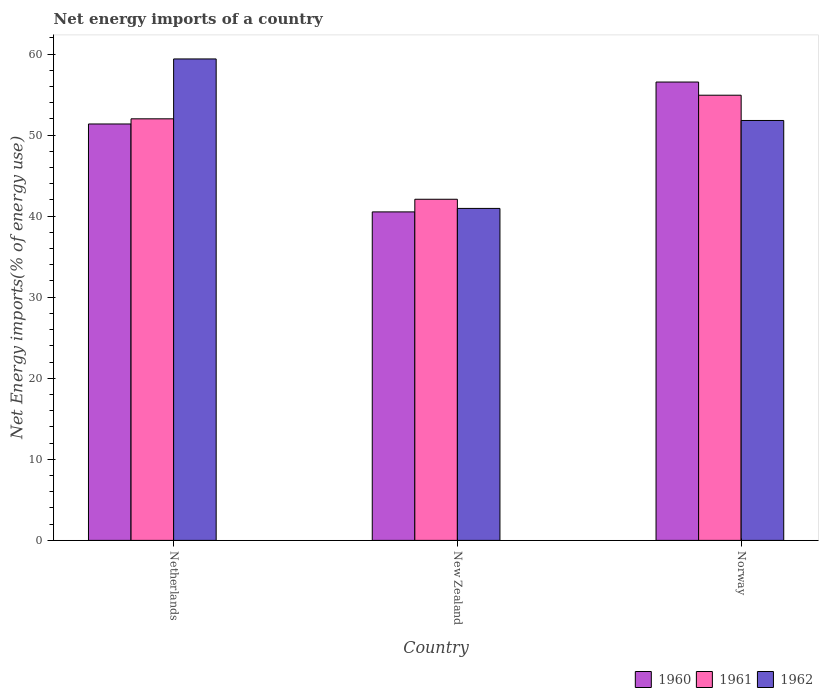Are the number of bars on each tick of the X-axis equal?
Give a very brief answer. Yes. How many bars are there on the 3rd tick from the right?
Your answer should be compact. 3. What is the label of the 2nd group of bars from the left?
Offer a terse response. New Zealand. In how many cases, is the number of bars for a given country not equal to the number of legend labels?
Your answer should be compact. 0. What is the net energy imports in 1962 in Netherlands?
Your response must be concise. 59.39. Across all countries, what is the maximum net energy imports in 1960?
Offer a very short reply. 56.54. Across all countries, what is the minimum net energy imports in 1960?
Offer a very short reply. 40.52. In which country was the net energy imports in 1961 minimum?
Keep it short and to the point. New Zealand. What is the total net energy imports in 1962 in the graph?
Offer a very short reply. 152.14. What is the difference between the net energy imports in 1962 in New Zealand and that in Norway?
Keep it short and to the point. -10.85. What is the difference between the net energy imports in 1962 in Netherlands and the net energy imports in 1960 in Norway?
Ensure brevity in your answer.  2.85. What is the average net energy imports in 1961 per country?
Give a very brief answer. 49.67. What is the difference between the net energy imports of/in 1961 and net energy imports of/in 1960 in Netherlands?
Your answer should be very brief. 0.64. What is the ratio of the net energy imports in 1962 in New Zealand to that in Norway?
Make the answer very short. 0.79. Is the net energy imports in 1961 in Netherlands less than that in New Zealand?
Provide a short and direct response. No. What is the difference between the highest and the second highest net energy imports in 1960?
Provide a succinct answer. 16.02. What is the difference between the highest and the lowest net energy imports in 1962?
Your response must be concise. 18.44. In how many countries, is the net energy imports in 1962 greater than the average net energy imports in 1962 taken over all countries?
Ensure brevity in your answer.  2. Is the sum of the net energy imports in 1962 in New Zealand and Norway greater than the maximum net energy imports in 1960 across all countries?
Offer a terse response. Yes. What does the 3rd bar from the left in Netherlands represents?
Your response must be concise. 1962. What does the 1st bar from the right in Norway represents?
Provide a succinct answer. 1962. Is it the case that in every country, the sum of the net energy imports in 1961 and net energy imports in 1960 is greater than the net energy imports in 1962?
Offer a very short reply. Yes. How many bars are there?
Your response must be concise. 9. How many countries are there in the graph?
Your response must be concise. 3. What is the difference between two consecutive major ticks on the Y-axis?
Give a very brief answer. 10. Are the values on the major ticks of Y-axis written in scientific E-notation?
Your response must be concise. No. What is the title of the graph?
Keep it short and to the point. Net energy imports of a country. Does "1972" appear as one of the legend labels in the graph?
Make the answer very short. No. What is the label or title of the X-axis?
Your answer should be compact. Country. What is the label or title of the Y-axis?
Offer a very short reply. Net Energy imports(% of energy use). What is the Net Energy imports(% of energy use) of 1960 in Netherlands?
Ensure brevity in your answer.  51.37. What is the Net Energy imports(% of energy use) of 1961 in Netherlands?
Offer a very short reply. 52. What is the Net Energy imports(% of energy use) in 1962 in Netherlands?
Give a very brief answer. 59.39. What is the Net Energy imports(% of energy use) in 1960 in New Zealand?
Your response must be concise. 40.52. What is the Net Energy imports(% of energy use) of 1961 in New Zealand?
Keep it short and to the point. 42.08. What is the Net Energy imports(% of energy use) in 1962 in New Zealand?
Your response must be concise. 40.95. What is the Net Energy imports(% of energy use) of 1960 in Norway?
Your answer should be very brief. 56.54. What is the Net Energy imports(% of energy use) of 1961 in Norway?
Ensure brevity in your answer.  54.92. What is the Net Energy imports(% of energy use) in 1962 in Norway?
Ensure brevity in your answer.  51.8. Across all countries, what is the maximum Net Energy imports(% of energy use) in 1960?
Provide a short and direct response. 56.54. Across all countries, what is the maximum Net Energy imports(% of energy use) in 1961?
Make the answer very short. 54.92. Across all countries, what is the maximum Net Energy imports(% of energy use) of 1962?
Make the answer very short. 59.39. Across all countries, what is the minimum Net Energy imports(% of energy use) in 1960?
Your answer should be compact. 40.52. Across all countries, what is the minimum Net Energy imports(% of energy use) in 1961?
Make the answer very short. 42.08. Across all countries, what is the minimum Net Energy imports(% of energy use) of 1962?
Your answer should be very brief. 40.95. What is the total Net Energy imports(% of energy use) in 1960 in the graph?
Provide a succinct answer. 148.43. What is the total Net Energy imports(% of energy use) in 1961 in the graph?
Offer a very short reply. 149. What is the total Net Energy imports(% of energy use) of 1962 in the graph?
Give a very brief answer. 152.14. What is the difference between the Net Energy imports(% of energy use) in 1960 in Netherlands and that in New Zealand?
Make the answer very short. 10.85. What is the difference between the Net Energy imports(% of energy use) of 1961 in Netherlands and that in New Zealand?
Provide a succinct answer. 9.92. What is the difference between the Net Energy imports(% of energy use) of 1962 in Netherlands and that in New Zealand?
Provide a short and direct response. 18.44. What is the difference between the Net Energy imports(% of energy use) of 1960 in Netherlands and that in Norway?
Make the answer very short. -5.17. What is the difference between the Net Energy imports(% of energy use) of 1961 in Netherlands and that in Norway?
Provide a succinct answer. -2.91. What is the difference between the Net Energy imports(% of energy use) in 1962 in Netherlands and that in Norway?
Give a very brief answer. 7.59. What is the difference between the Net Energy imports(% of energy use) in 1960 in New Zealand and that in Norway?
Provide a short and direct response. -16.02. What is the difference between the Net Energy imports(% of energy use) of 1961 in New Zealand and that in Norway?
Ensure brevity in your answer.  -12.83. What is the difference between the Net Energy imports(% of energy use) in 1962 in New Zealand and that in Norway?
Offer a terse response. -10.85. What is the difference between the Net Energy imports(% of energy use) of 1960 in Netherlands and the Net Energy imports(% of energy use) of 1961 in New Zealand?
Provide a succinct answer. 9.29. What is the difference between the Net Energy imports(% of energy use) of 1960 in Netherlands and the Net Energy imports(% of energy use) of 1962 in New Zealand?
Your answer should be very brief. 10.42. What is the difference between the Net Energy imports(% of energy use) of 1961 in Netherlands and the Net Energy imports(% of energy use) of 1962 in New Zealand?
Ensure brevity in your answer.  11.05. What is the difference between the Net Energy imports(% of energy use) in 1960 in Netherlands and the Net Energy imports(% of energy use) in 1961 in Norway?
Keep it short and to the point. -3.55. What is the difference between the Net Energy imports(% of energy use) of 1960 in Netherlands and the Net Energy imports(% of energy use) of 1962 in Norway?
Provide a short and direct response. -0.43. What is the difference between the Net Energy imports(% of energy use) in 1961 in Netherlands and the Net Energy imports(% of energy use) in 1962 in Norway?
Ensure brevity in your answer.  0.2. What is the difference between the Net Energy imports(% of energy use) of 1960 in New Zealand and the Net Energy imports(% of energy use) of 1961 in Norway?
Ensure brevity in your answer.  -14.39. What is the difference between the Net Energy imports(% of energy use) in 1960 in New Zealand and the Net Energy imports(% of energy use) in 1962 in Norway?
Provide a short and direct response. -11.28. What is the difference between the Net Energy imports(% of energy use) in 1961 in New Zealand and the Net Energy imports(% of energy use) in 1962 in Norway?
Your response must be concise. -9.72. What is the average Net Energy imports(% of energy use) of 1960 per country?
Keep it short and to the point. 49.48. What is the average Net Energy imports(% of energy use) in 1961 per country?
Provide a short and direct response. 49.67. What is the average Net Energy imports(% of energy use) of 1962 per country?
Offer a terse response. 50.71. What is the difference between the Net Energy imports(% of energy use) of 1960 and Net Energy imports(% of energy use) of 1961 in Netherlands?
Offer a terse response. -0.64. What is the difference between the Net Energy imports(% of energy use) in 1960 and Net Energy imports(% of energy use) in 1962 in Netherlands?
Give a very brief answer. -8.02. What is the difference between the Net Energy imports(% of energy use) of 1961 and Net Energy imports(% of energy use) of 1962 in Netherlands?
Offer a terse response. -7.39. What is the difference between the Net Energy imports(% of energy use) of 1960 and Net Energy imports(% of energy use) of 1961 in New Zealand?
Give a very brief answer. -1.56. What is the difference between the Net Energy imports(% of energy use) of 1960 and Net Energy imports(% of energy use) of 1962 in New Zealand?
Ensure brevity in your answer.  -0.43. What is the difference between the Net Energy imports(% of energy use) in 1961 and Net Energy imports(% of energy use) in 1962 in New Zealand?
Your answer should be compact. 1.13. What is the difference between the Net Energy imports(% of energy use) in 1960 and Net Energy imports(% of energy use) in 1961 in Norway?
Offer a very short reply. 1.62. What is the difference between the Net Energy imports(% of energy use) in 1960 and Net Energy imports(% of energy use) in 1962 in Norway?
Your response must be concise. 4.74. What is the difference between the Net Energy imports(% of energy use) of 1961 and Net Energy imports(% of energy use) of 1962 in Norway?
Offer a terse response. 3.12. What is the ratio of the Net Energy imports(% of energy use) in 1960 in Netherlands to that in New Zealand?
Give a very brief answer. 1.27. What is the ratio of the Net Energy imports(% of energy use) of 1961 in Netherlands to that in New Zealand?
Offer a terse response. 1.24. What is the ratio of the Net Energy imports(% of energy use) in 1962 in Netherlands to that in New Zealand?
Offer a terse response. 1.45. What is the ratio of the Net Energy imports(% of energy use) in 1960 in Netherlands to that in Norway?
Provide a succinct answer. 0.91. What is the ratio of the Net Energy imports(% of energy use) in 1961 in Netherlands to that in Norway?
Provide a short and direct response. 0.95. What is the ratio of the Net Energy imports(% of energy use) of 1962 in Netherlands to that in Norway?
Keep it short and to the point. 1.15. What is the ratio of the Net Energy imports(% of energy use) of 1960 in New Zealand to that in Norway?
Your answer should be very brief. 0.72. What is the ratio of the Net Energy imports(% of energy use) of 1961 in New Zealand to that in Norway?
Provide a short and direct response. 0.77. What is the ratio of the Net Energy imports(% of energy use) of 1962 in New Zealand to that in Norway?
Your response must be concise. 0.79. What is the difference between the highest and the second highest Net Energy imports(% of energy use) in 1960?
Your answer should be compact. 5.17. What is the difference between the highest and the second highest Net Energy imports(% of energy use) of 1961?
Offer a very short reply. 2.91. What is the difference between the highest and the second highest Net Energy imports(% of energy use) in 1962?
Offer a very short reply. 7.59. What is the difference between the highest and the lowest Net Energy imports(% of energy use) in 1960?
Provide a short and direct response. 16.02. What is the difference between the highest and the lowest Net Energy imports(% of energy use) in 1961?
Your answer should be very brief. 12.83. What is the difference between the highest and the lowest Net Energy imports(% of energy use) in 1962?
Provide a succinct answer. 18.44. 